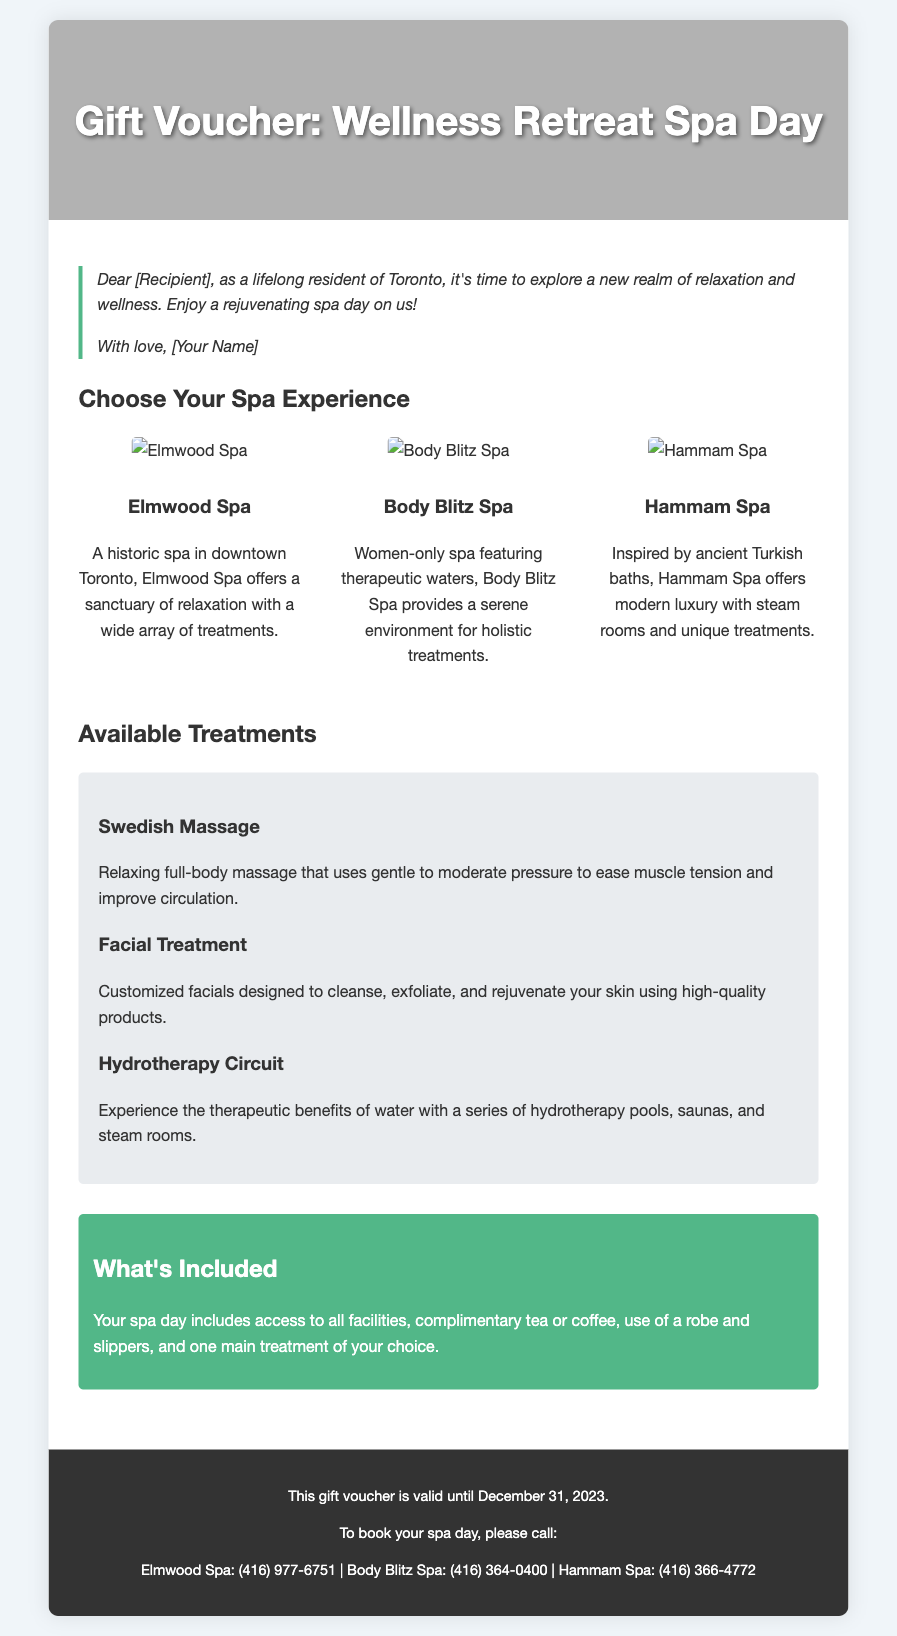what is the title of the voucher? The title of the voucher is prominently displayed at the top of the document, indicating the type of experience.
Answer: Gift Voucher: Wellness Retreat Spa Day how many spas are featured in the voucher? The document lists three specific spas that are included in the gift voucher.
Answer: three what type of massage is included among the available treatments? One of the treatments mentioned is a specific type of massage, which is listed under the available treatments section.
Answer: Swedish Massage what is the validity period of the voucher? The footer of the document clearly states the expiration date for the gift voucher.
Answer: December 31, 2023 what is included with the spa day experience? A section of the document outlines specific offerings that come with the spa day, providing details on amenities and services.
Answer: Access to all facilities, complimentary tea or coffee, use of a robe and slippers, and one main treatment of choice what is the phone number for Body Blitz Spa? The footer section of the voucher includes contact information for each spa, including phone numbers.
Answer: (416) 364-0400 